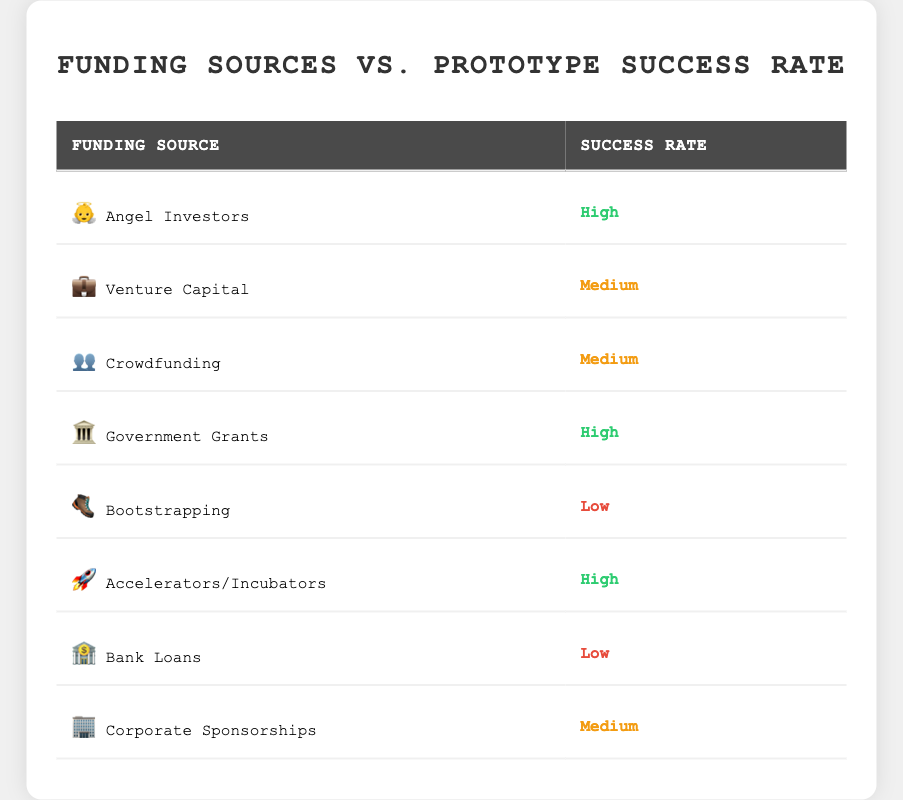What is the success rate of Angel Investors? The table directly lists Angel Investors under the "Funding Source" column and indicates its "Success Rate" as "High".
Answer: High Which funding source has the lowest success rate? By reviewing the "Success Rate" column, Bootstrapping and Bank Loans both have a "Low" success rate. Given the requirement to identify only one, Bootstrapping is the first one listed with a low success rate.
Answer: Bootstrapping How many funding sources have a medium success rate? Scanning through the table, we identify Venture Capital, Crowdfunding, and Corporate Sponsorships as having a "Medium" success rate. There are three such funding sources.
Answer: 3 Is the success rate of Government Grants higher than that of Venture Capital? Government Grants is listed with a "High" success rate, while Venture Capital has a "Medium" success rate. Since "High" is indeed greater than "Medium", the answer is affirmative.
Answer: Yes What is the combined success rate for the funding sources with high success rates? The table identifies three funding sources—Angel Investors, Government Grants, and Accelerators/Incubators—with "High" success rates. Therefore, to answer this mathematically, if we assign values (High=3, Medium=2, Low=1), then the total for high success rates is 3 (count of high sources) x 3 (value for high success) = 9
Answer: 9 